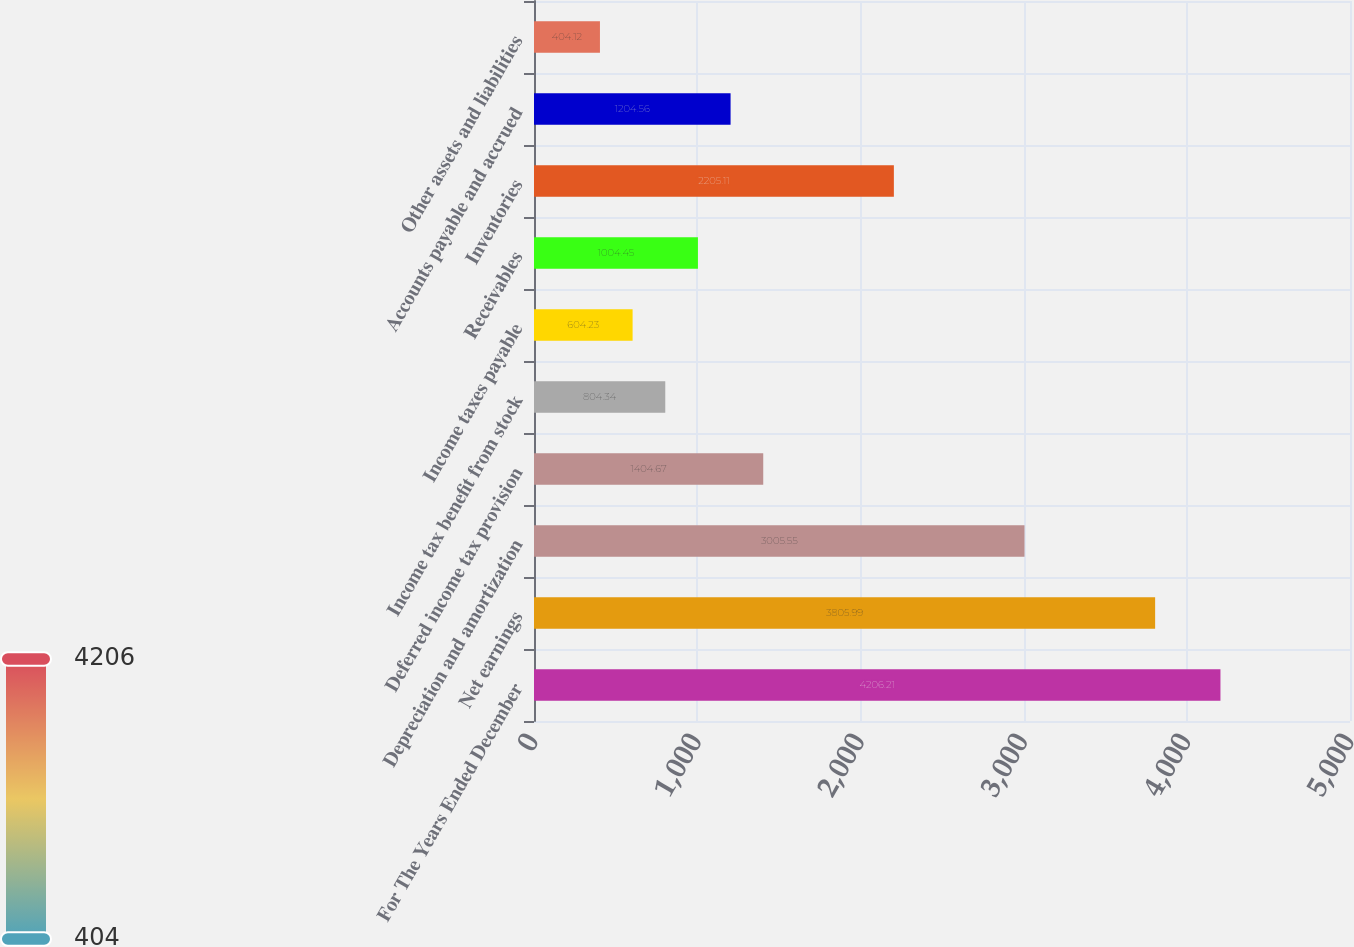<chart> <loc_0><loc_0><loc_500><loc_500><bar_chart><fcel>For The Years Ended December<fcel>Net earnings<fcel>Depreciation and amortization<fcel>Deferred income tax provision<fcel>Income tax benefit from stock<fcel>Income taxes payable<fcel>Receivables<fcel>Inventories<fcel>Accounts payable and accrued<fcel>Other assets and liabilities<nl><fcel>4206.21<fcel>3805.99<fcel>3005.55<fcel>1404.67<fcel>804.34<fcel>604.23<fcel>1004.45<fcel>2205.11<fcel>1204.56<fcel>404.12<nl></chart> 